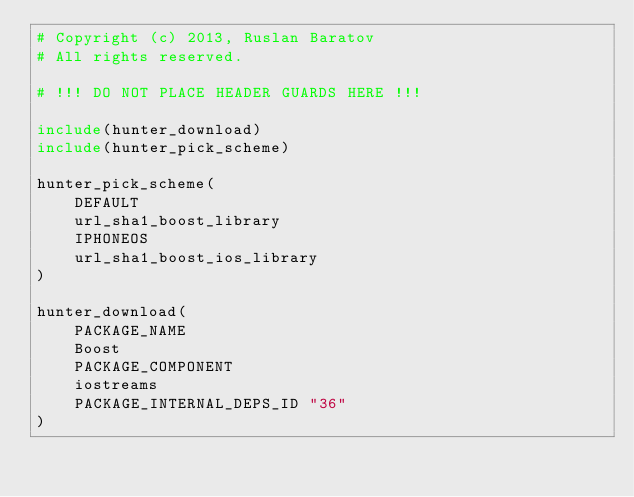Convert code to text. <code><loc_0><loc_0><loc_500><loc_500><_CMake_># Copyright (c) 2013, Ruslan Baratov
# All rights reserved.

# !!! DO NOT PLACE HEADER GUARDS HERE !!!

include(hunter_download)
include(hunter_pick_scheme)

hunter_pick_scheme(
    DEFAULT
    url_sha1_boost_library
    IPHONEOS
    url_sha1_boost_ios_library
)

hunter_download(
    PACKAGE_NAME
    Boost
    PACKAGE_COMPONENT
    iostreams
    PACKAGE_INTERNAL_DEPS_ID "36"
)
</code> 